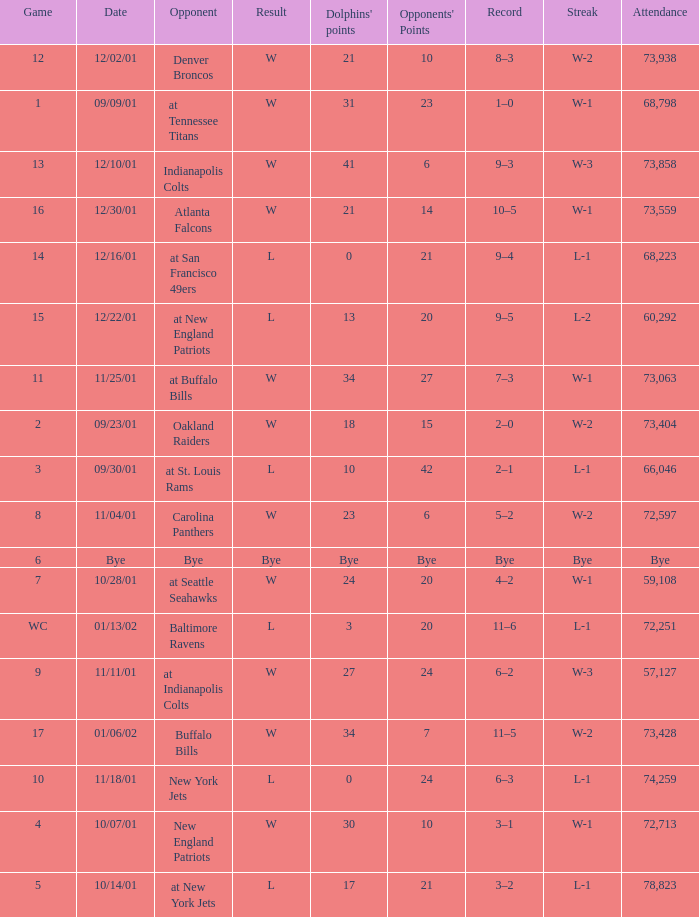What is the streak for game 2? W-2. 